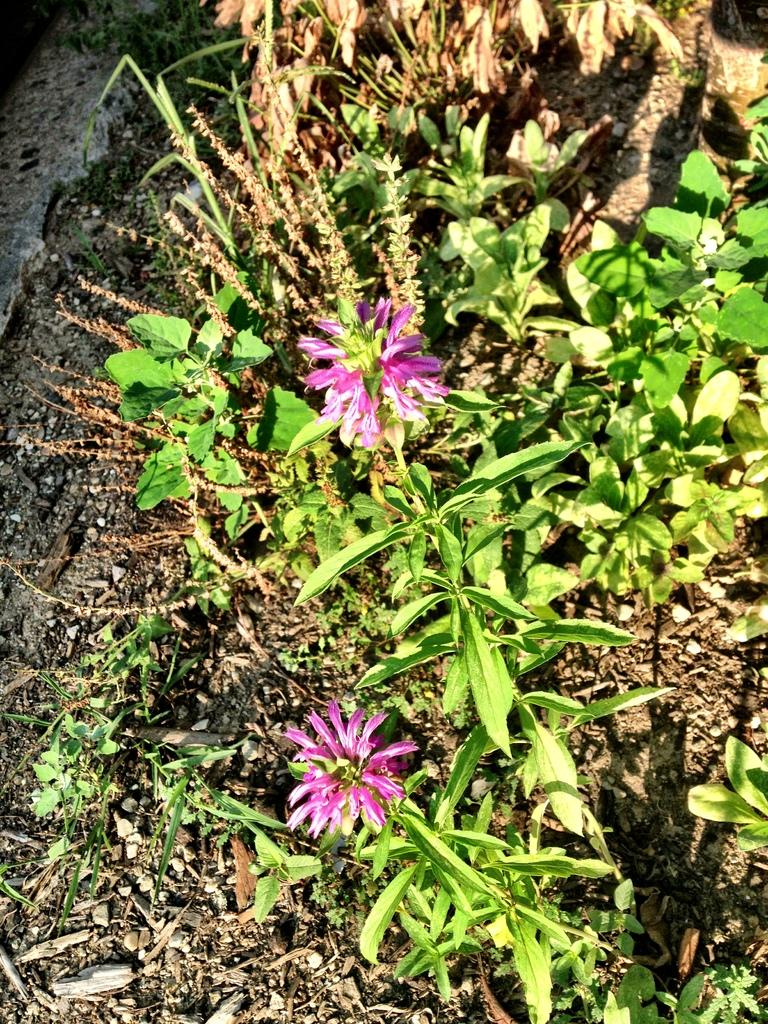What is the main subject of the image? The main subject of the image is plants with flowers. What color are the flowers? The flowers are pink in color. What can be seen in the background of the image? In the background, there is grass, soil, and dry seeds. How many pies are being brushed in the image? There are no pies or brushes present in the image. What thought is being expressed by the flowers in the image? The flowers in the image do not express any thoughts, as they are inanimate objects. 